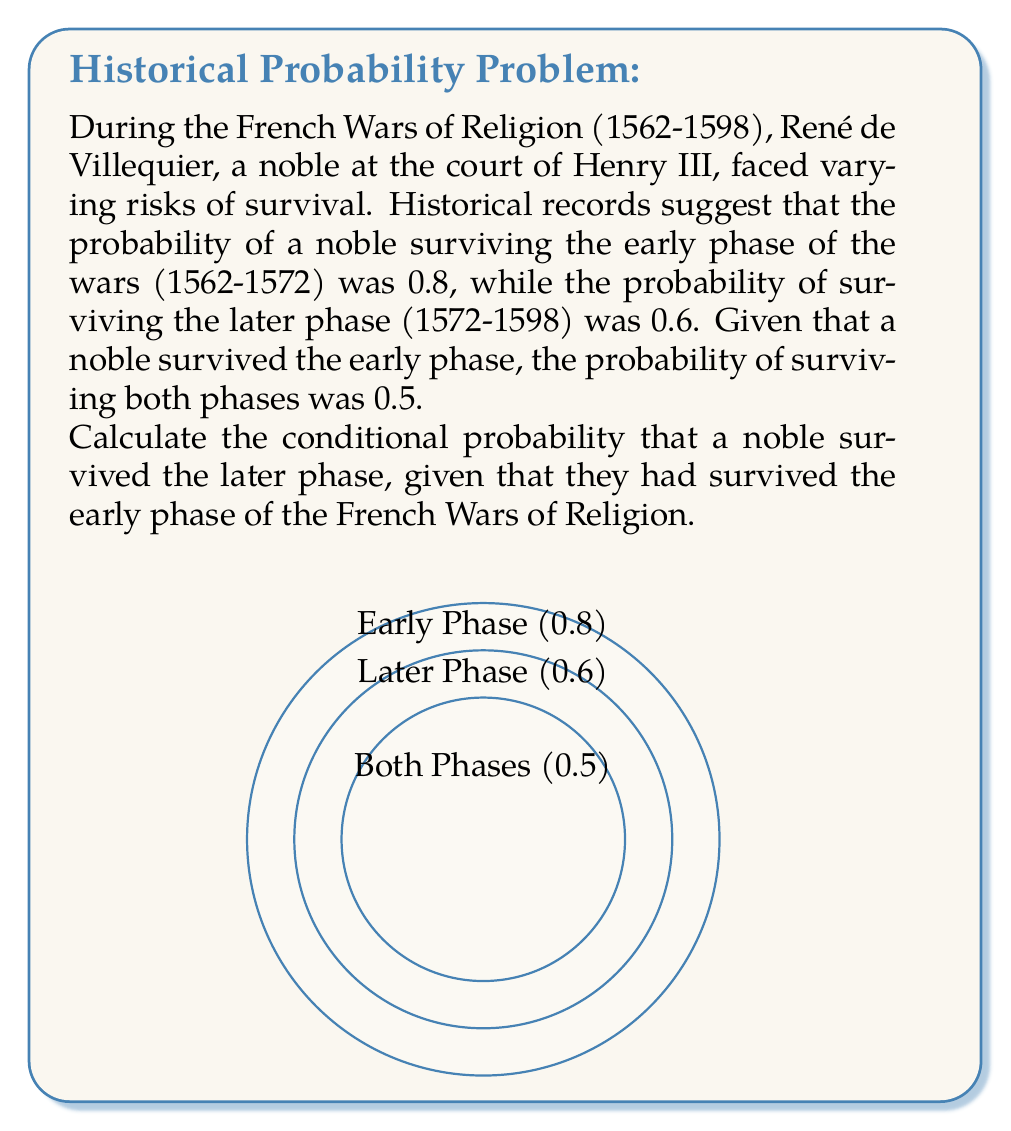Provide a solution to this math problem. To solve this problem, we'll use the definition of conditional probability and the given information:

1) Let's define our events:
   E: Surviving the early phase
   L: Surviving the later phase

2) We're given:
   P(E) = 0.8 (probability of surviving the early phase)
   P(L) = 0.6 (probability of surviving the later phase)
   P(E ∩ L) = 0.5 (probability of surviving both phases)

3) We need to find P(L|E), which is the conditional probability of surviving the later phase given survival of the early phase.

4) The formula for conditional probability is:

   $$P(L|E) = \frac{P(E ∩ L)}{P(E)}$$

5) We have all the information to plug into this formula:

   $$P(L|E) = \frac{0.5}{0.8}$$

6) Calculating:

   $$P(L|E) = \frac{5}{8} = 0.625$$

Therefore, the conditional probability that a noble survived the later phase, given that they had survived the early phase, is 0.625 or 62.5%.
Answer: $\frac{5}{8}$ or 0.625 